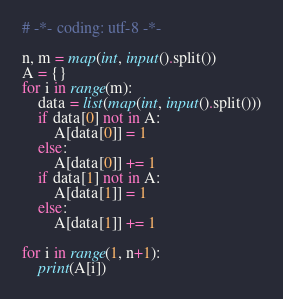Convert code to text. <code><loc_0><loc_0><loc_500><loc_500><_Python_># -*- coding: utf-8 -*-

n, m = map(int, input().split())
A = {}
for i in range(m):
    data = list(map(int, input().split()))
    if data[0] not in A:
        A[data[0]] = 1
    else:
        A[data[0]] += 1
    if data[1] not in A:
        A[data[1]] = 1
    else:
        A[data[1]] += 1

for i in range(1, n+1):
    print(A[i])
</code> 